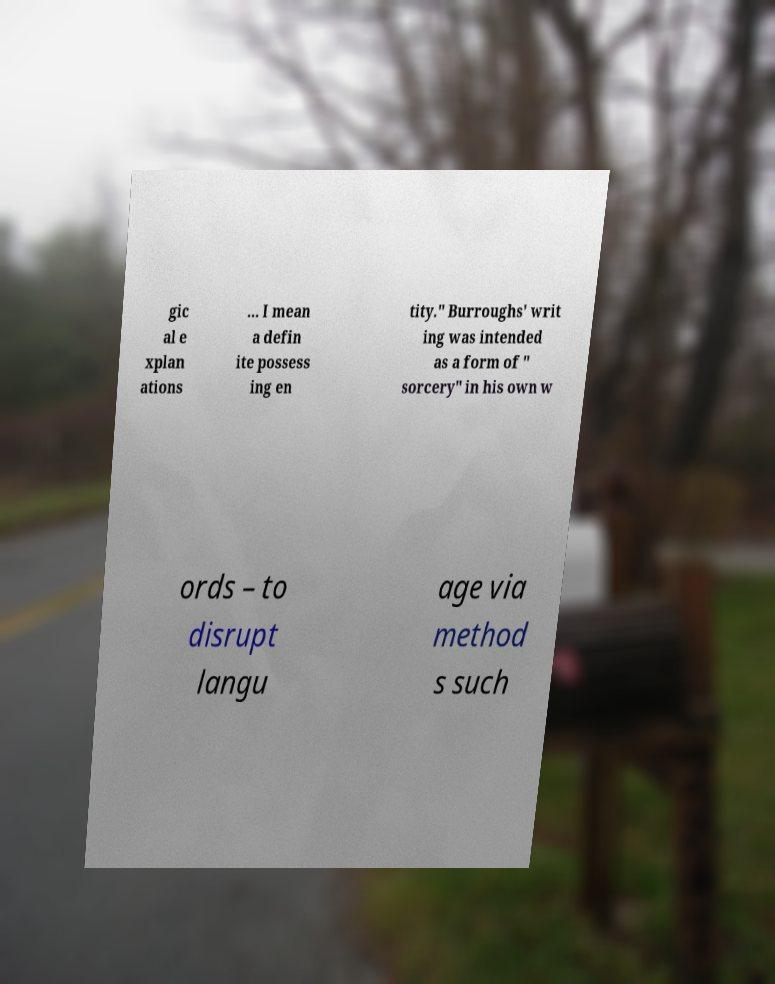Can you read and provide the text displayed in the image?This photo seems to have some interesting text. Can you extract and type it out for me? gic al e xplan ations ... I mean a defin ite possess ing en tity." Burroughs' writ ing was intended as a form of " sorcery" in his own w ords – to disrupt langu age via method s such 